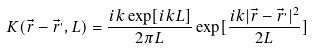<formula> <loc_0><loc_0><loc_500><loc_500>K ( { \vec { r } } - { \vec { r } } ^ { , } , L ) = { \frac { i k \exp [ i k L ] } { 2 \pi L } } \exp [ { \frac { i k | { \vec { r } } - { \vec { r } } ^ { , } | ^ { 2 } } { 2 L } } ]</formula> 